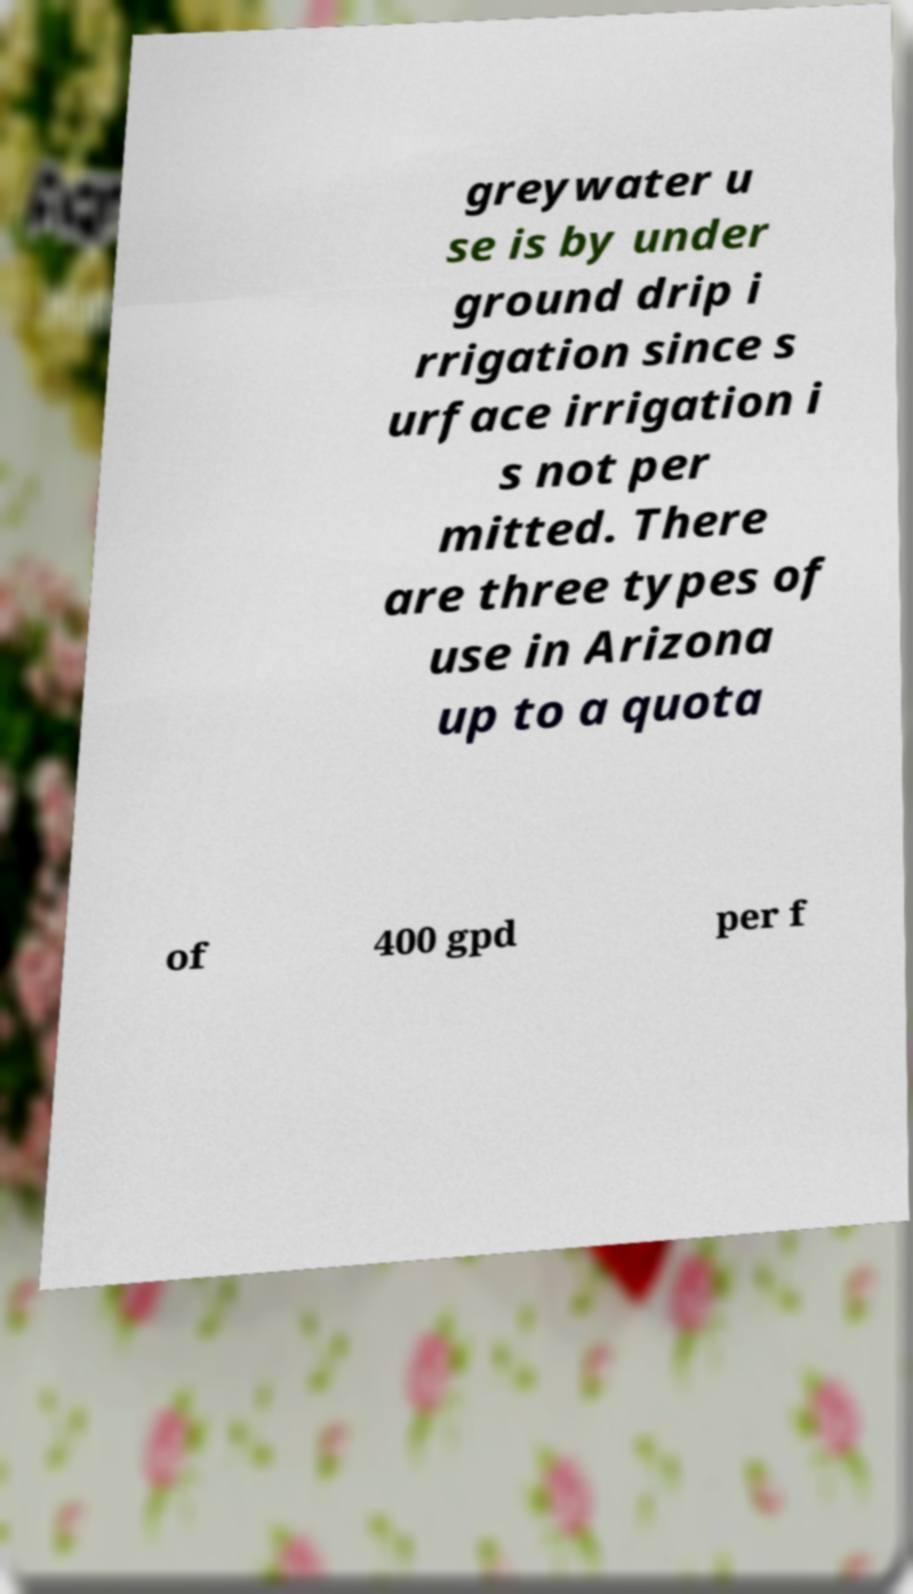Please identify and transcribe the text found in this image. greywater u se is by under ground drip i rrigation since s urface irrigation i s not per mitted. There are three types of use in Arizona up to a quota of 400 gpd per f 